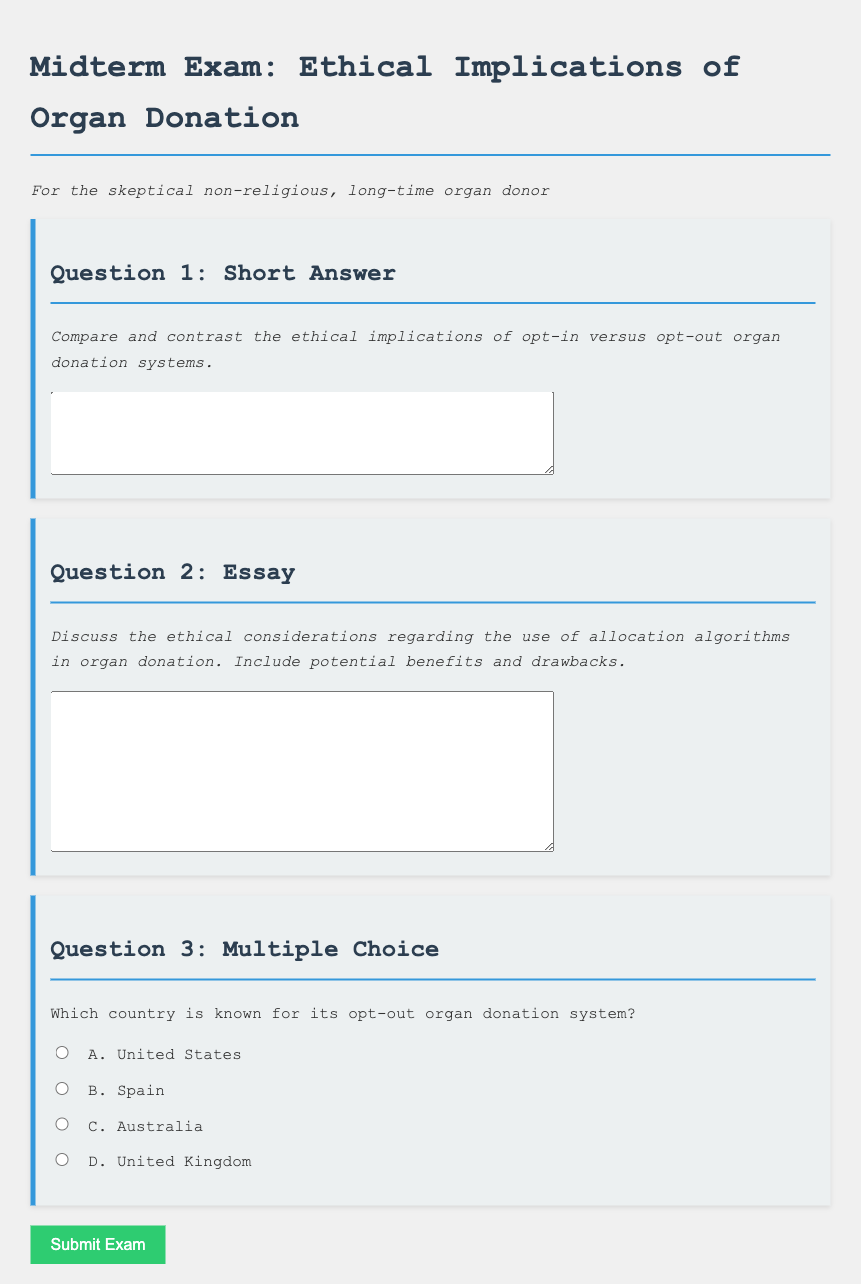What is the title of the document? The title is displayed prominently at the top of the document and refers to the subject matter of the content.
Answer: Organ Donation Ethics Midterm Exam How many questions are in the exam? The document outlines a total of three questions, including a mixture of formats such as short answer, essay, and multiple-choice.
Answer: 3 What format is used for the third question? The document specifies that the third question is a multiple-choice format as indicated by the list of options provided.
Answer: Multiple Choice What is the required action when the exam form is submitted? The document includes an event listener that triggers an alert when the form is submitted, indicating successful submission.
Answer: Alert Which ethical topic is addressed in the essay question? The essay question specifically asks about allocation algorithms, which is a key ethical consideration in organ donation practices.
Answer: Allocation algorithms In which section of the document is the phrase "For the skeptical non-religious, long-time organ donor" found? This phrase is included as a descriptor under the main title of the exam, setting the context for the intended audience.
Answer: Under the title What color is used for the button to submit the exam? The button color is styled as a shade of green, specifically hexadecimal color value #2ecc71, which is indicated in the document's CSS section.
Answer: Green 